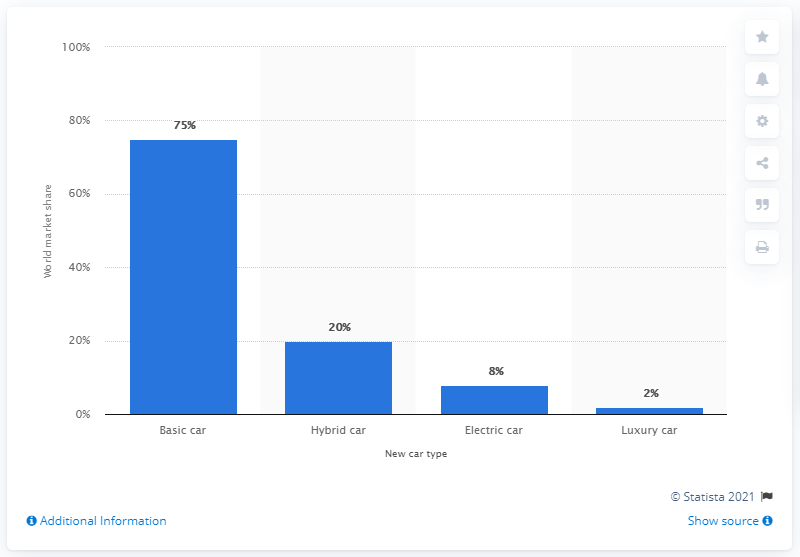Draw attention to some important aspects in this diagram. According to predictions, the world market share of electric cars is expected to be approximately 8% in 2020. 